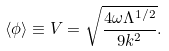<formula> <loc_0><loc_0><loc_500><loc_500>\langle \phi \rangle \equiv V = \sqrt { \frac { 4 \omega \Lambda ^ { 1 / 2 } } { 9 k ^ { 2 } } } .</formula> 